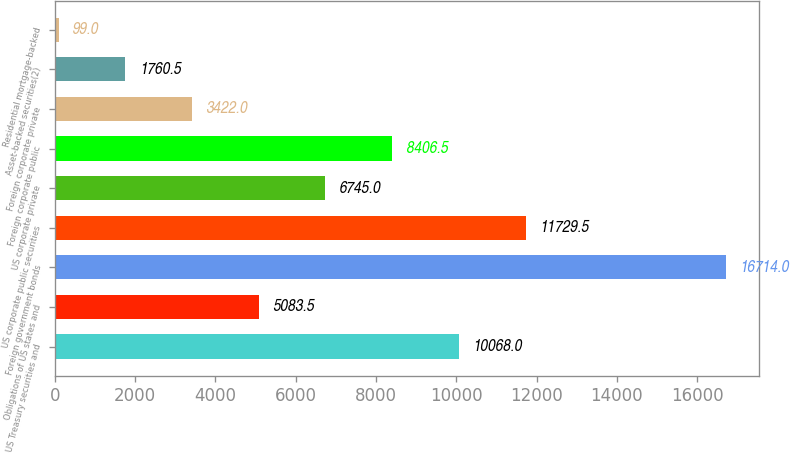<chart> <loc_0><loc_0><loc_500><loc_500><bar_chart><fcel>US Treasury securities and<fcel>Obligations of US states and<fcel>Foreign government bonds<fcel>US corporate public securities<fcel>US corporate private<fcel>Foreign corporate public<fcel>Foreign corporate private<fcel>Asset-backed securities(2)<fcel>Residential mortgage-backed<nl><fcel>10068<fcel>5083.5<fcel>16714<fcel>11729.5<fcel>6745<fcel>8406.5<fcel>3422<fcel>1760.5<fcel>99<nl></chart> 